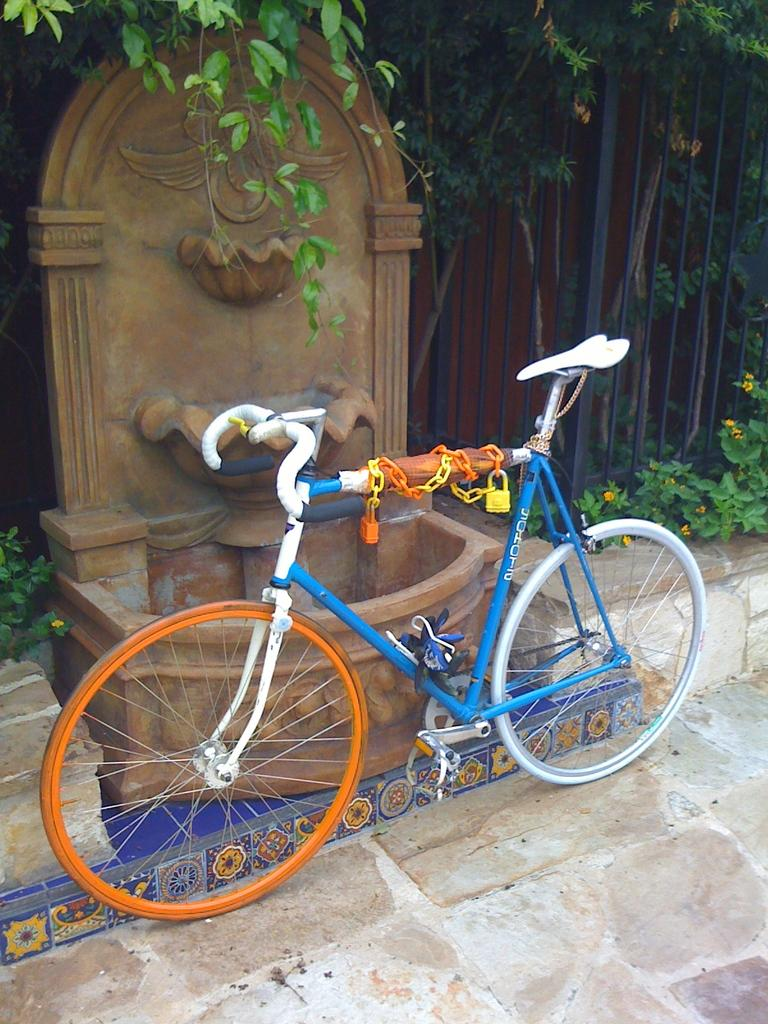What is the main object in the image? There is a bicycle in the image. What is attached to the bicycle? There is a chain attached to the bicycle. What might be used to secure the bicycle? There are locks in the image. What is a unique feature in the image? There is a designed stone in the image. What is present to protect the bicycle? There is a grille in the image. What type of vegetation is visible in the image? There are plants, flowers, and leaves in the image. What type of lipstick is the person wearing in the image? There is no person visible in the image, and therefore no lipstick or person wearing lipstick can be observed. What type of suit is the person wearing in the image? There is no person visible in the image, and therefore no suit or person wearing a suit can be observed. What type of spade is being used to dig in the image? There is no spade or digging activity present in the image. 